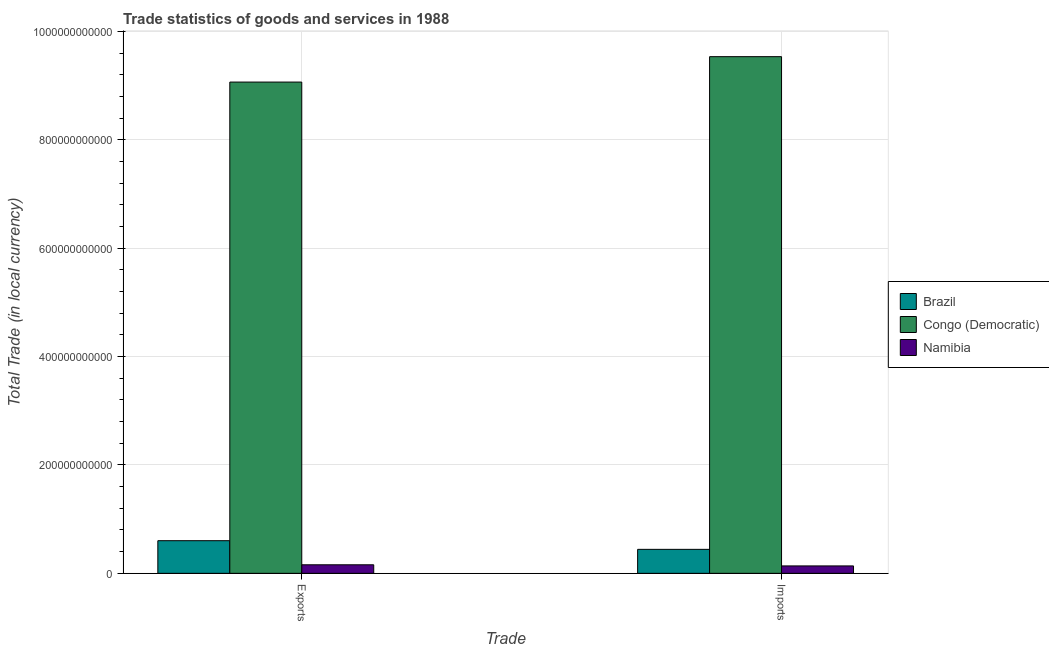Are the number of bars per tick equal to the number of legend labels?
Offer a terse response. Yes. Are the number of bars on each tick of the X-axis equal?
Give a very brief answer. Yes. How many bars are there on the 2nd tick from the left?
Provide a succinct answer. 3. How many bars are there on the 2nd tick from the right?
Ensure brevity in your answer.  3. What is the label of the 1st group of bars from the left?
Provide a succinct answer. Exports. What is the imports of goods and services in Namibia?
Provide a succinct answer. 1.37e+1. Across all countries, what is the maximum imports of goods and services?
Your response must be concise. 9.53e+11. Across all countries, what is the minimum imports of goods and services?
Keep it short and to the point. 1.37e+1. In which country was the export of goods and services maximum?
Make the answer very short. Congo (Democratic). In which country was the export of goods and services minimum?
Provide a short and direct response. Namibia. What is the total export of goods and services in the graph?
Your answer should be compact. 9.83e+11. What is the difference between the export of goods and services in Namibia and that in Brazil?
Your response must be concise. -4.45e+1. What is the difference between the export of goods and services in Namibia and the imports of goods and services in Congo (Democratic)?
Ensure brevity in your answer.  -9.38e+11. What is the average imports of goods and services per country?
Provide a short and direct response. 3.37e+11. What is the difference between the export of goods and services and imports of goods and services in Brazil?
Your answer should be very brief. 1.60e+1. What is the ratio of the imports of goods and services in Brazil to that in Congo (Democratic)?
Your response must be concise. 0.05. Is the imports of goods and services in Namibia less than that in Brazil?
Provide a short and direct response. Yes. In how many countries, is the imports of goods and services greater than the average imports of goods and services taken over all countries?
Your answer should be very brief. 1. What does the 1st bar from the left in Exports represents?
Ensure brevity in your answer.  Brazil. What does the 3rd bar from the right in Imports represents?
Your answer should be very brief. Brazil. What is the difference between two consecutive major ticks on the Y-axis?
Ensure brevity in your answer.  2.00e+11. Are the values on the major ticks of Y-axis written in scientific E-notation?
Your answer should be very brief. No. Does the graph contain any zero values?
Offer a very short reply. No. How many legend labels are there?
Provide a short and direct response. 3. How are the legend labels stacked?
Provide a short and direct response. Vertical. What is the title of the graph?
Keep it short and to the point. Trade statistics of goods and services in 1988. What is the label or title of the X-axis?
Provide a short and direct response. Trade. What is the label or title of the Y-axis?
Give a very brief answer. Total Trade (in local currency). What is the Total Trade (in local currency) of Brazil in Exports?
Your response must be concise. 6.02e+1. What is the Total Trade (in local currency) in Congo (Democratic) in Exports?
Your answer should be compact. 9.07e+11. What is the Total Trade (in local currency) of Namibia in Exports?
Provide a short and direct response. 1.58e+1. What is the Total Trade (in local currency) of Brazil in Imports?
Your answer should be compact. 4.43e+1. What is the Total Trade (in local currency) of Congo (Democratic) in Imports?
Offer a very short reply. 9.53e+11. What is the Total Trade (in local currency) of Namibia in Imports?
Your answer should be compact. 1.37e+1. Across all Trade, what is the maximum Total Trade (in local currency) of Brazil?
Provide a succinct answer. 6.02e+1. Across all Trade, what is the maximum Total Trade (in local currency) of Congo (Democratic)?
Ensure brevity in your answer.  9.53e+11. Across all Trade, what is the maximum Total Trade (in local currency) of Namibia?
Give a very brief answer. 1.58e+1. Across all Trade, what is the minimum Total Trade (in local currency) of Brazil?
Provide a succinct answer. 4.43e+1. Across all Trade, what is the minimum Total Trade (in local currency) in Congo (Democratic)?
Keep it short and to the point. 9.07e+11. Across all Trade, what is the minimum Total Trade (in local currency) in Namibia?
Your answer should be very brief. 1.37e+1. What is the total Total Trade (in local currency) of Brazil in the graph?
Offer a terse response. 1.04e+11. What is the total Total Trade (in local currency) in Congo (Democratic) in the graph?
Your answer should be compact. 1.86e+12. What is the total Total Trade (in local currency) of Namibia in the graph?
Provide a succinct answer. 2.95e+1. What is the difference between the Total Trade (in local currency) of Brazil in Exports and that in Imports?
Make the answer very short. 1.60e+1. What is the difference between the Total Trade (in local currency) in Congo (Democratic) in Exports and that in Imports?
Offer a terse response. -4.69e+1. What is the difference between the Total Trade (in local currency) of Namibia in Exports and that in Imports?
Your answer should be very brief. 2.09e+09. What is the difference between the Total Trade (in local currency) of Brazil in Exports and the Total Trade (in local currency) of Congo (Democratic) in Imports?
Provide a succinct answer. -8.93e+11. What is the difference between the Total Trade (in local currency) in Brazil in Exports and the Total Trade (in local currency) in Namibia in Imports?
Provide a short and direct response. 4.65e+1. What is the difference between the Total Trade (in local currency) in Congo (Democratic) in Exports and the Total Trade (in local currency) in Namibia in Imports?
Your response must be concise. 8.93e+11. What is the average Total Trade (in local currency) in Brazil per Trade?
Make the answer very short. 5.22e+1. What is the average Total Trade (in local currency) in Congo (Democratic) per Trade?
Give a very brief answer. 9.30e+11. What is the average Total Trade (in local currency) of Namibia per Trade?
Ensure brevity in your answer.  1.47e+1. What is the difference between the Total Trade (in local currency) in Brazil and Total Trade (in local currency) in Congo (Democratic) in Exports?
Give a very brief answer. -8.46e+11. What is the difference between the Total Trade (in local currency) of Brazil and Total Trade (in local currency) of Namibia in Exports?
Your response must be concise. 4.45e+1. What is the difference between the Total Trade (in local currency) of Congo (Democratic) and Total Trade (in local currency) of Namibia in Exports?
Provide a succinct answer. 8.91e+11. What is the difference between the Total Trade (in local currency) in Brazil and Total Trade (in local currency) in Congo (Democratic) in Imports?
Give a very brief answer. -9.09e+11. What is the difference between the Total Trade (in local currency) in Brazil and Total Trade (in local currency) in Namibia in Imports?
Offer a terse response. 3.06e+1. What is the difference between the Total Trade (in local currency) of Congo (Democratic) and Total Trade (in local currency) of Namibia in Imports?
Provide a succinct answer. 9.40e+11. What is the ratio of the Total Trade (in local currency) of Brazil in Exports to that in Imports?
Offer a very short reply. 1.36. What is the ratio of the Total Trade (in local currency) in Congo (Democratic) in Exports to that in Imports?
Provide a succinct answer. 0.95. What is the ratio of the Total Trade (in local currency) in Namibia in Exports to that in Imports?
Your answer should be very brief. 1.15. What is the difference between the highest and the second highest Total Trade (in local currency) in Brazil?
Make the answer very short. 1.60e+1. What is the difference between the highest and the second highest Total Trade (in local currency) in Congo (Democratic)?
Keep it short and to the point. 4.69e+1. What is the difference between the highest and the second highest Total Trade (in local currency) in Namibia?
Provide a short and direct response. 2.09e+09. What is the difference between the highest and the lowest Total Trade (in local currency) in Brazil?
Your answer should be compact. 1.60e+1. What is the difference between the highest and the lowest Total Trade (in local currency) in Congo (Democratic)?
Make the answer very short. 4.69e+1. What is the difference between the highest and the lowest Total Trade (in local currency) of Namibia?
Provide a succinct answer. 2.09e+09. 